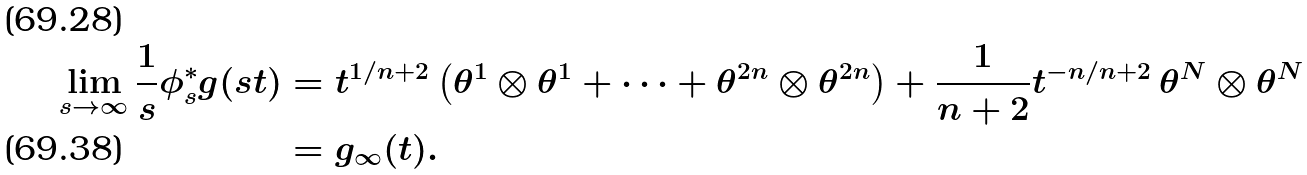<formula> <loc_0><loc_0><loc_500><loc_500>\lim _ { s \rightarrow \infty } \frac { 1 } { s } \phi _ { s } ^ { * } g ( s t ) & = t ^ { 1 / n + 2 } \left ( \theta ^ { 1 } \otimes \theta ^ { 1 } + \cdots + \theta ^ { 2 n } \otimes \theta ^ { 2 n } \right ) + \frac { 1 } { n + 2 } t ^ { - n / n + 2 } \, \theta ^ { N } \otimes \theta ^ { N } \\ & = g _ { \infty } ( t ) .</formula> 